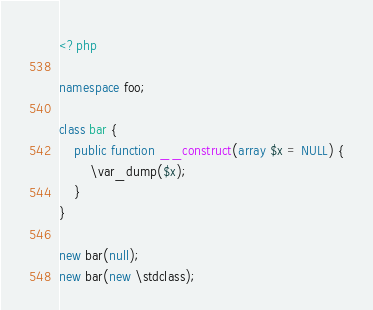Convert code to text. <code><loc_0><loc_0><loc_500><loc_500><_PHP_><?php

namespace foo;

class bar {
	public function __construct(array $x = NULL) {
		\var_dump($x);
	}
}

new bar(null);
new bar(new \stdclass);

</code> 